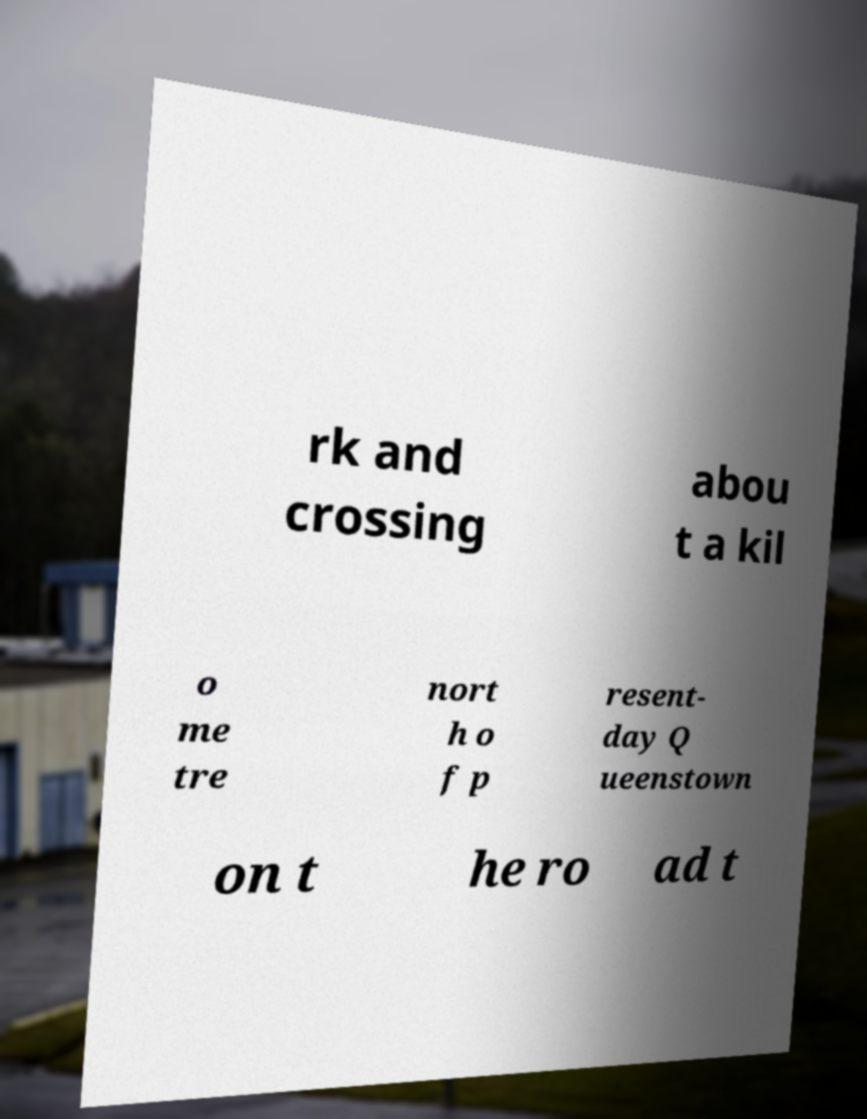Could you assist in decoding the text presented in this image and type it out clearly? rk and crossing abou t a kil o me tre nort h o f p resent- day Q ueenstown on t he ro ad t 